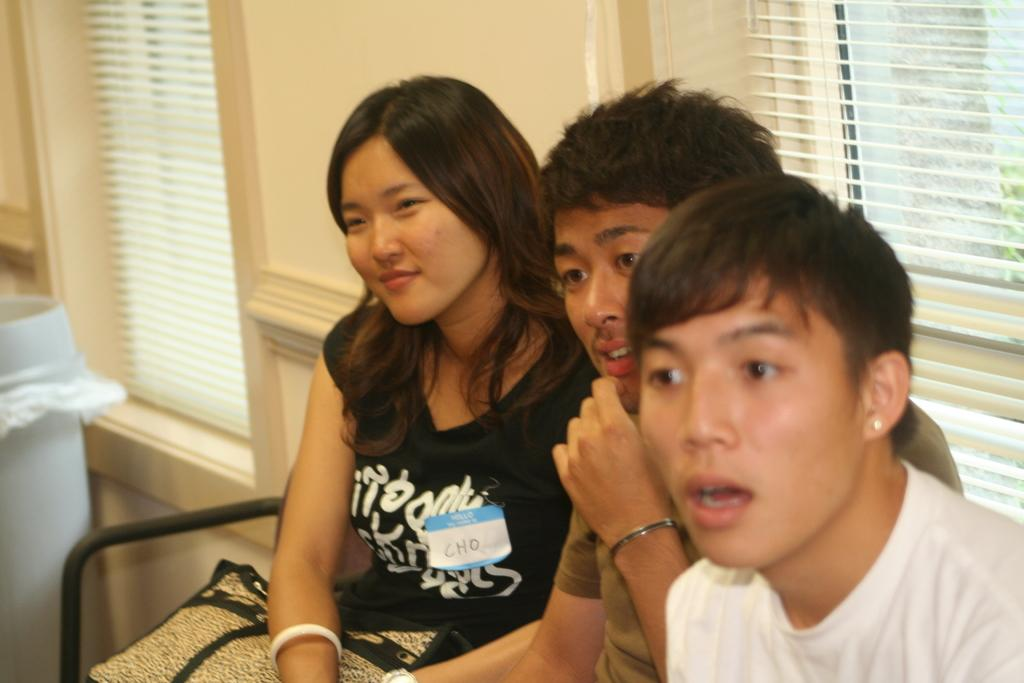What is the main subject of the image? There is a person sitting on a bench in the image. Where is the bench located in the image? The bench is in the center of the image. What can be seen on the left side of the image? There is a window and a dustbin on the left side of the image. What is visible in the background of the image? There is a wall and another window in the background of the image. Can you tell me how many toes the dog has in the image? There is no dog present in the image, so it is not possible to determine the number of toes the dog might have. 